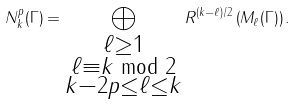<formula> <loc_0><loc_0><loc_500><loc_500>N _ { k } ^ { p } ( \Gamma ) = \bigoplus _ { \substack { \ell \geq 1 \\ \ell \equiv k \bmod { 2 } \\ k - 2 p \leq \ell \leq k } } R ^ { ( k - \ell ) / 2 } \left ( M _ { \ell } ( \Gamma ) \right ) .</formula> 